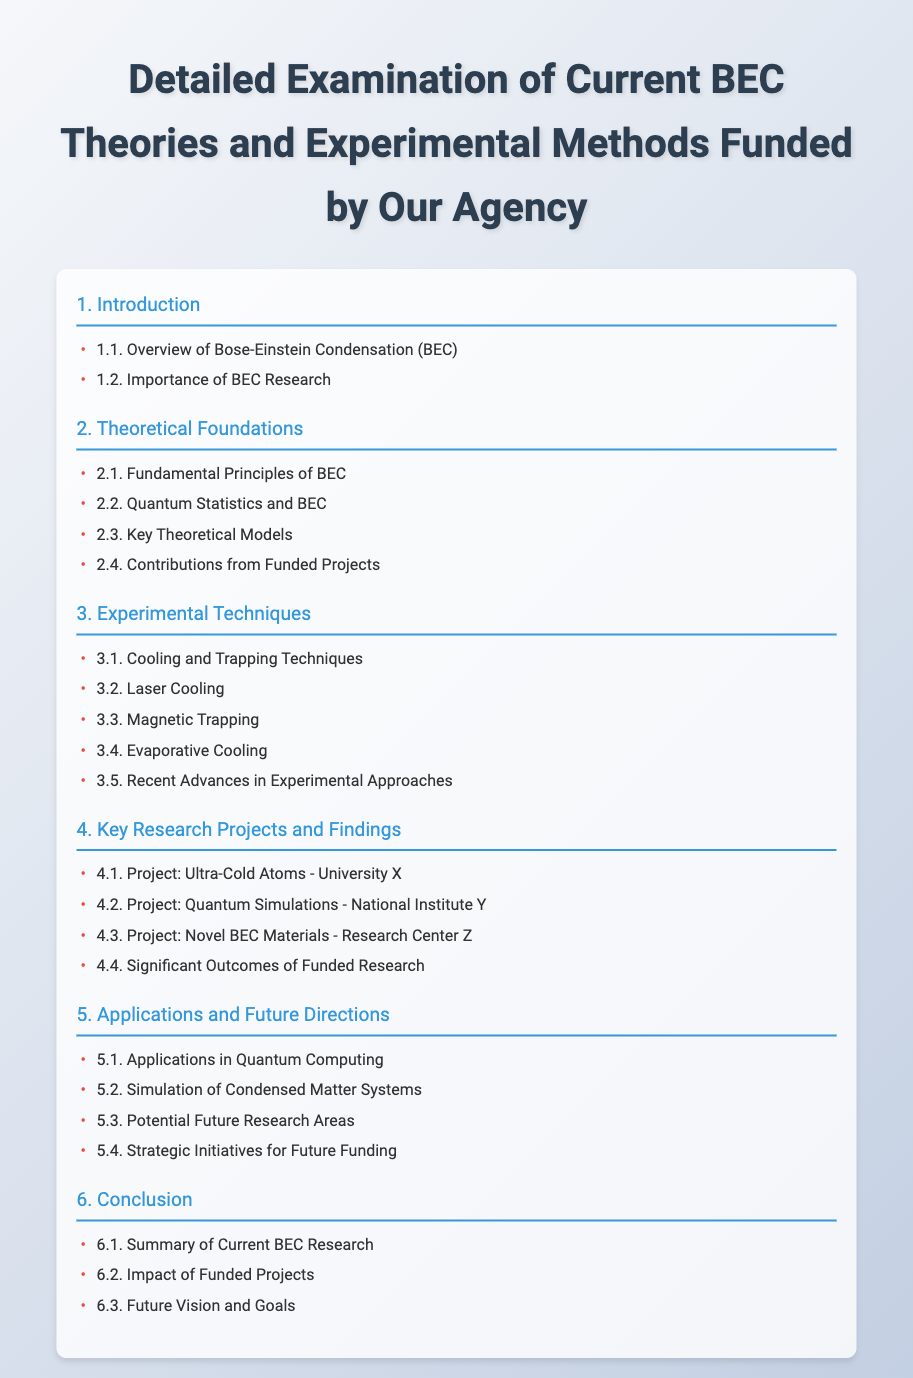What is the title of the document? The title of the document is provided at the top of the rendered page.
Answer: Detailed Examination of Current BEC Theories and Experimental Methods Funded by Our Agency What is section 3 about? Section 3 is titled "Experimental Techniques," which indicates the focus on practical methods in the field.
Answer: Experimental Techniques How many projects are listed in section 4? Section 4 lists a total of four research projects related to BEC.
Answer: 4 What is the first subsection of section 2? The first subsection of section 2, "Theoretical Foundations," provides insight into foundational concepts of BEC.
Answer: Fundamental Principles of BEC What is one potential future research area mentioned? The document highlights areas for future inquiry, specifically in connection to BEC advancements.
Answer: Potential Future Research Areas What is the last section of the document? The last section summarizes the findings and implications of the research discussed throughout the document.
Answer: Conclusion What subsection addresses the applications of BEC in technology? This subsection discusses the relevance of BEC technology and its applications, particularly in quantum fields.
Answer: Applications in Quantum Computing What unique feature is present in subsections? The subsections have a visual cue indicated by a bullet point to enhance clarity.
Answer: Bullet points 